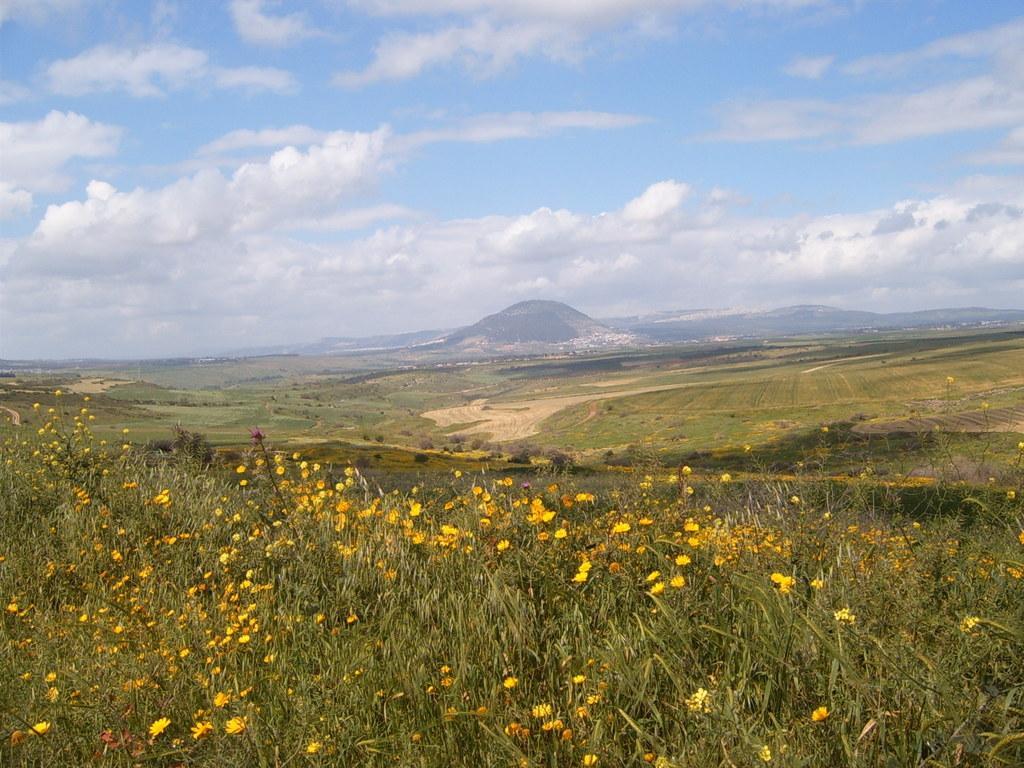Describe this image in one or two sentences. There are plants having yellow color flowers on the ground. In the background, there are plants, trees and grass on the ground, there are mountains and there are clouds in the blue sky. 